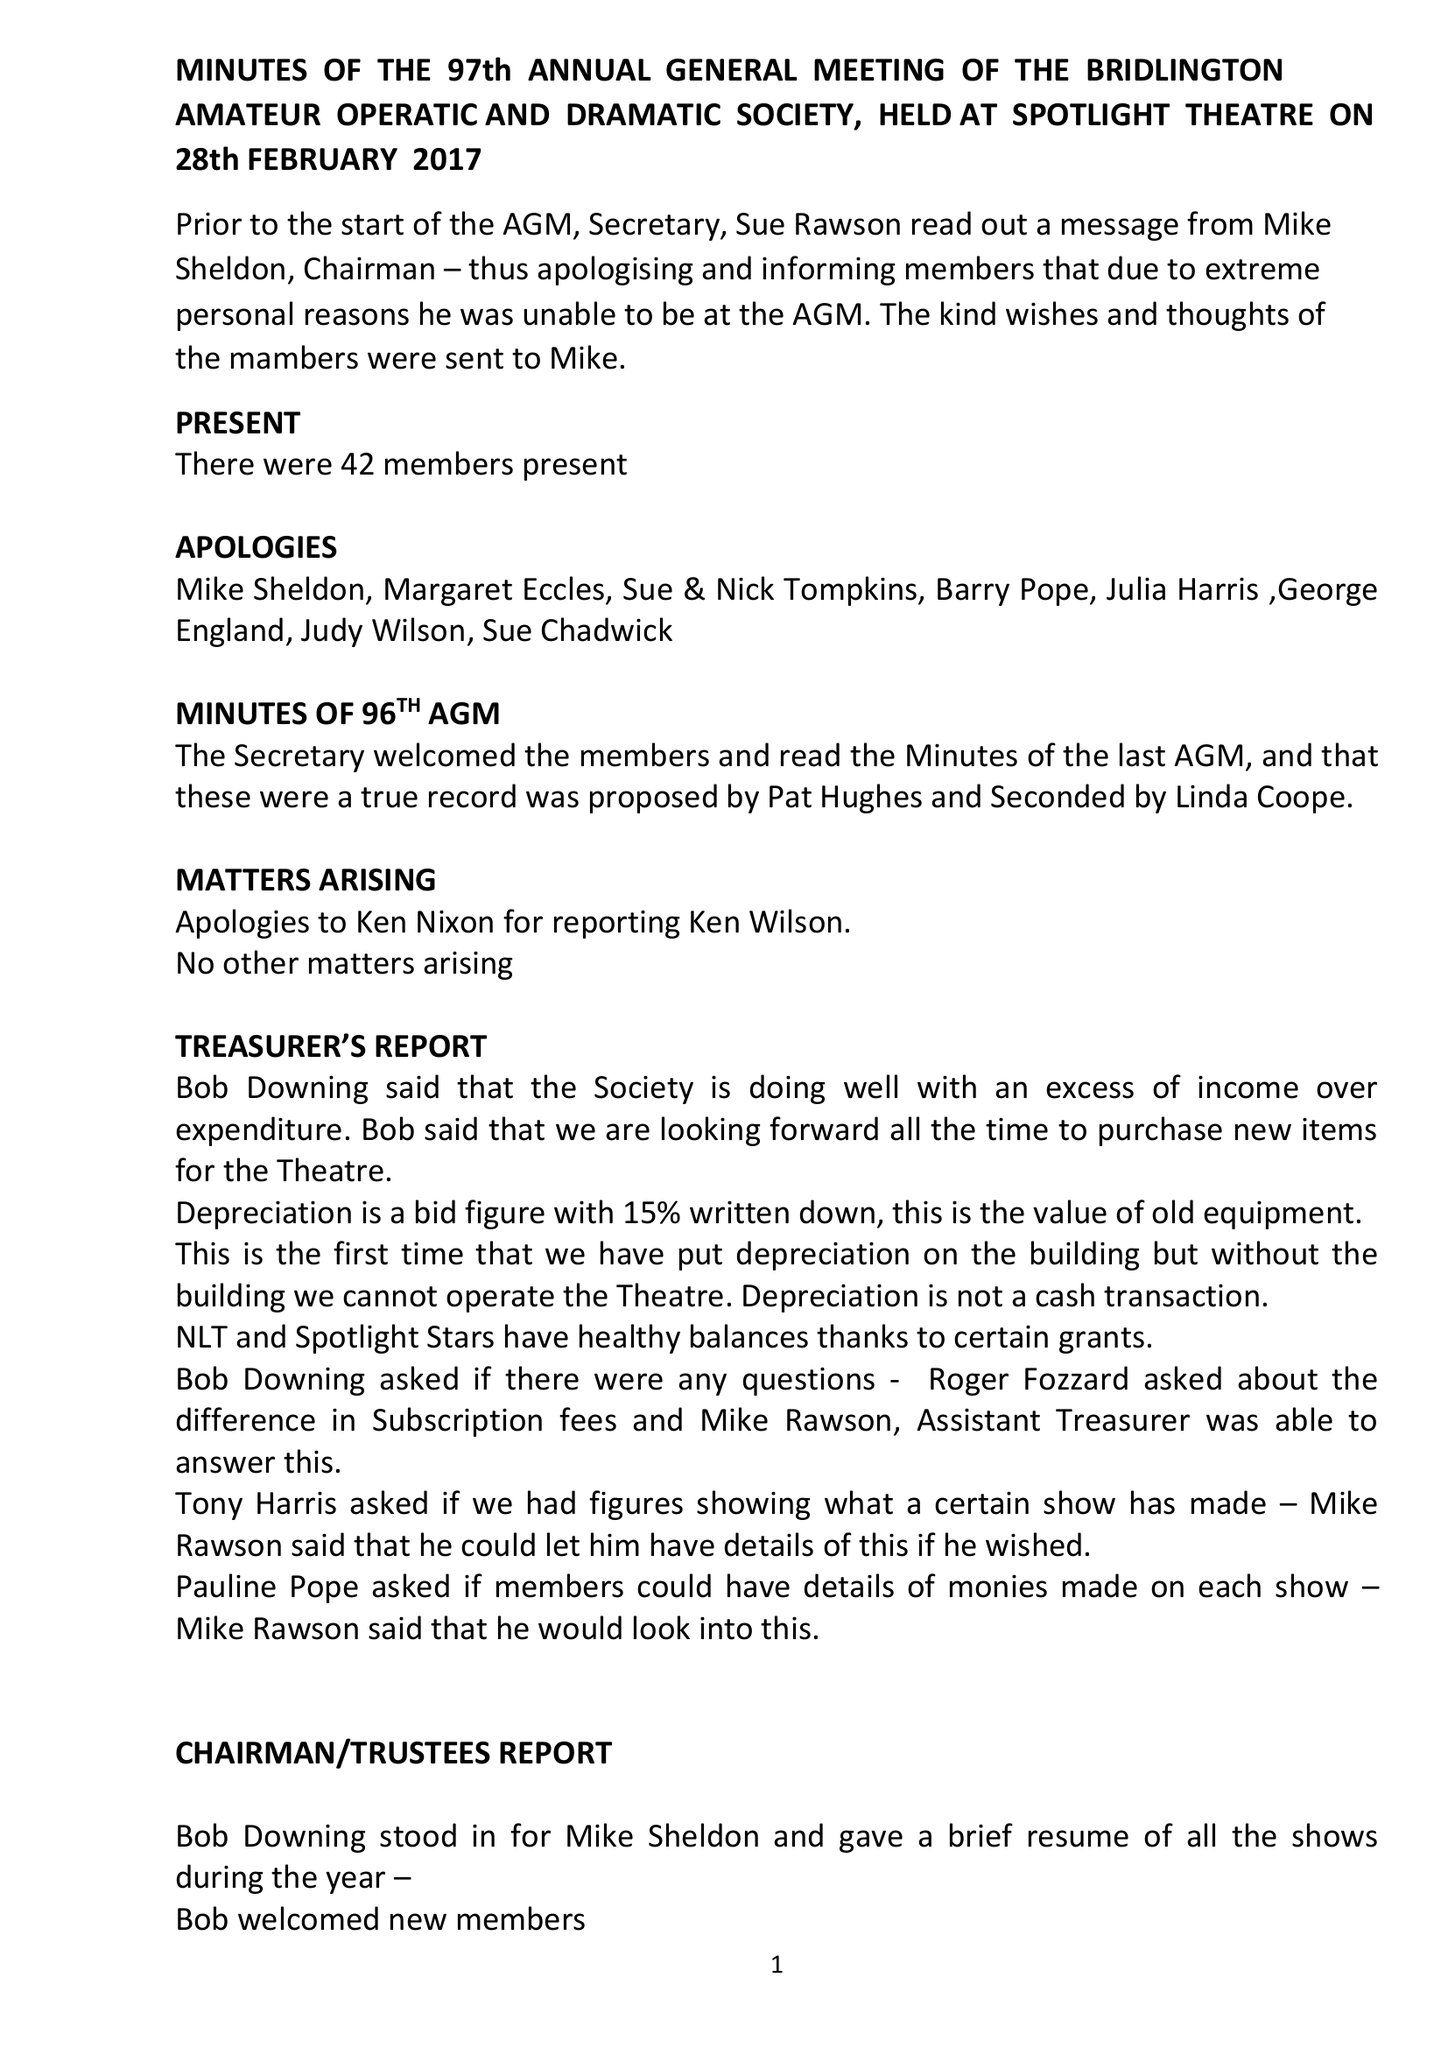What is the value for the report_date?
Answer the question using a single word or phrase. 2016-12-31 